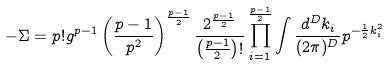Convert formula to latex. <formula><loc_0><loc_0><loc_500><loc_500>- \Sigma = p ! g ^ { p - 1 } \left ( \frac { p - 1 } { p ^ { 2 } } \right ) ^ { \frac { p - 1 } { 2 } } \frac { 2 ^ { \frac { p - 1 } { 2 } } } { \left ( \frac { p - 1 } { 2 } \right ) ! } \prod _ { i = 1 } ^ { \frac { p - 1 } { 2 } } \int \frac { d ^ { D } k _ { i } } { ( 2 \pi ) ^ { D } } p ^ { - \frac { 1 } { 2 } k _ { i } ^ { 2 } }</formula> 